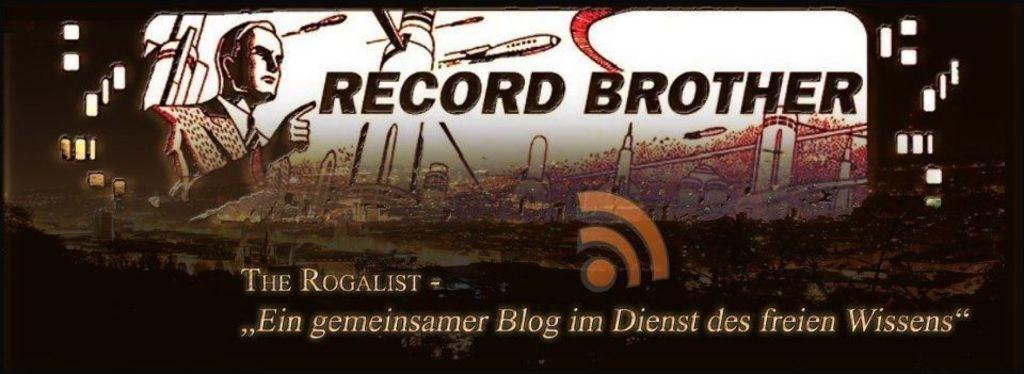<image>
Offer a succinct explanation of the picture presented. A cartoonish man pointing his finger at the words RECORD BROTHER. 